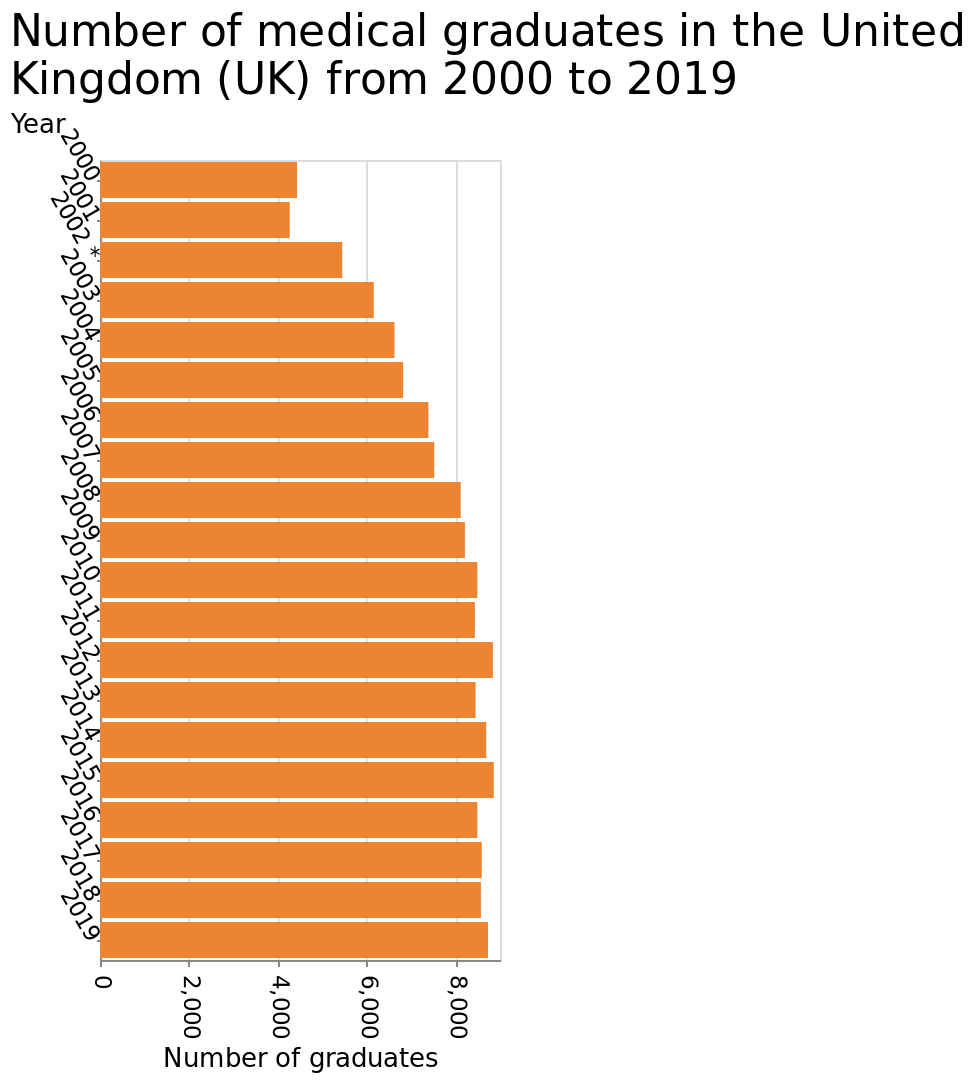<image>
How has the number of medical graduates in the United Kingdom changed over the years? The number of medical graduates in the United Kingdom has shown a consistent upward trend from 2000 to 2019. 